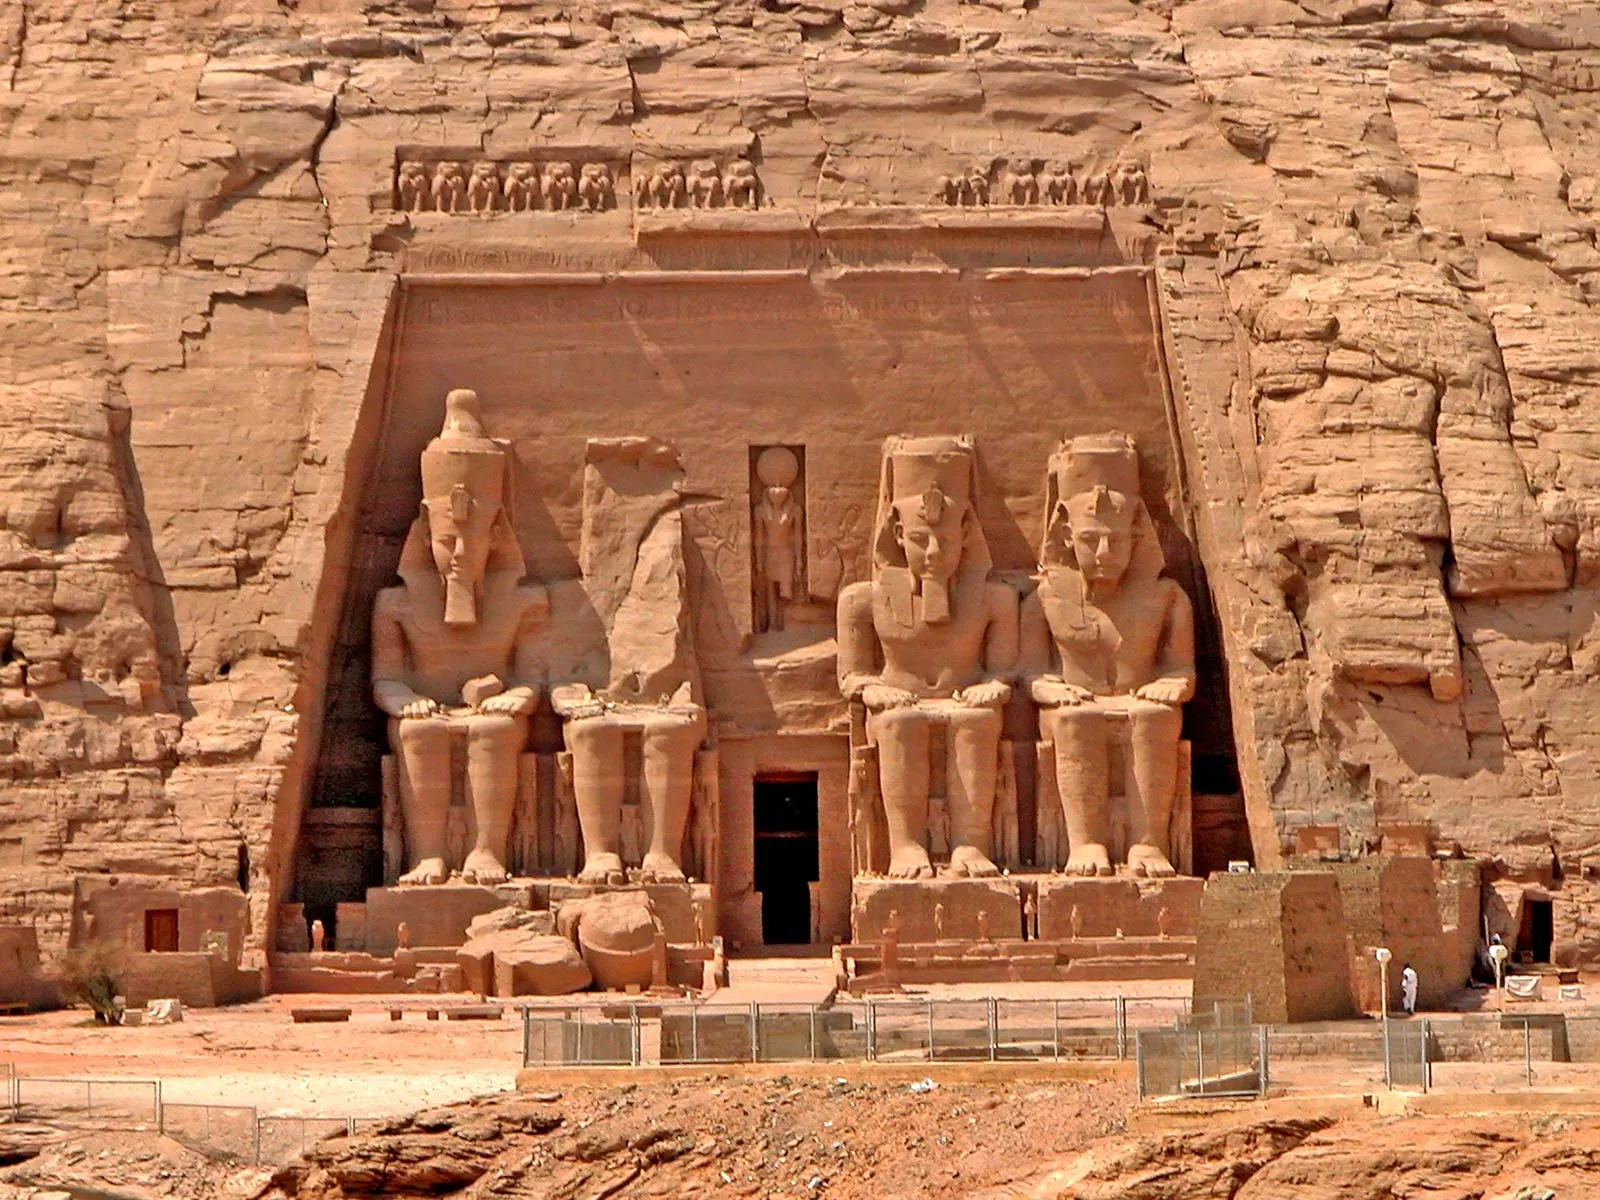Envision an alternate history where Ramesses II used advanced alien technology. How would the temple and the society around it appear? In an alternate history where Ramesses II harnessed advanced alien technology, the Abu Simbel temple would be a marvel of futuristic design integrated with ancient aesthetics. The colossal statues would be animated, capable of movement and speech, narrating historical tales with holographic visuals projected from their eyes. The temple walls would be made of impervious materials, glowing with hieroglyphs that shift and realign to show new messages. The society around it would be futuristic yet deeply rooted in tradition; pyramidal structures would float mid-air, connected by energy bridges. Transportation would be based on anti-gravity chariots, and agriculture would thrive with climate-controlled environments. Medicine would be highly advanced, with longevity treatments allowing lifespans stretching for centuries. The very air would hum with the low vibrations of alien machinery, blending seamlessly with the chants of the priests. This society would balance the ancient honor of their deities with the benefits of alien technology, creating a utopia that bridged the realms of the gods and the universe. 